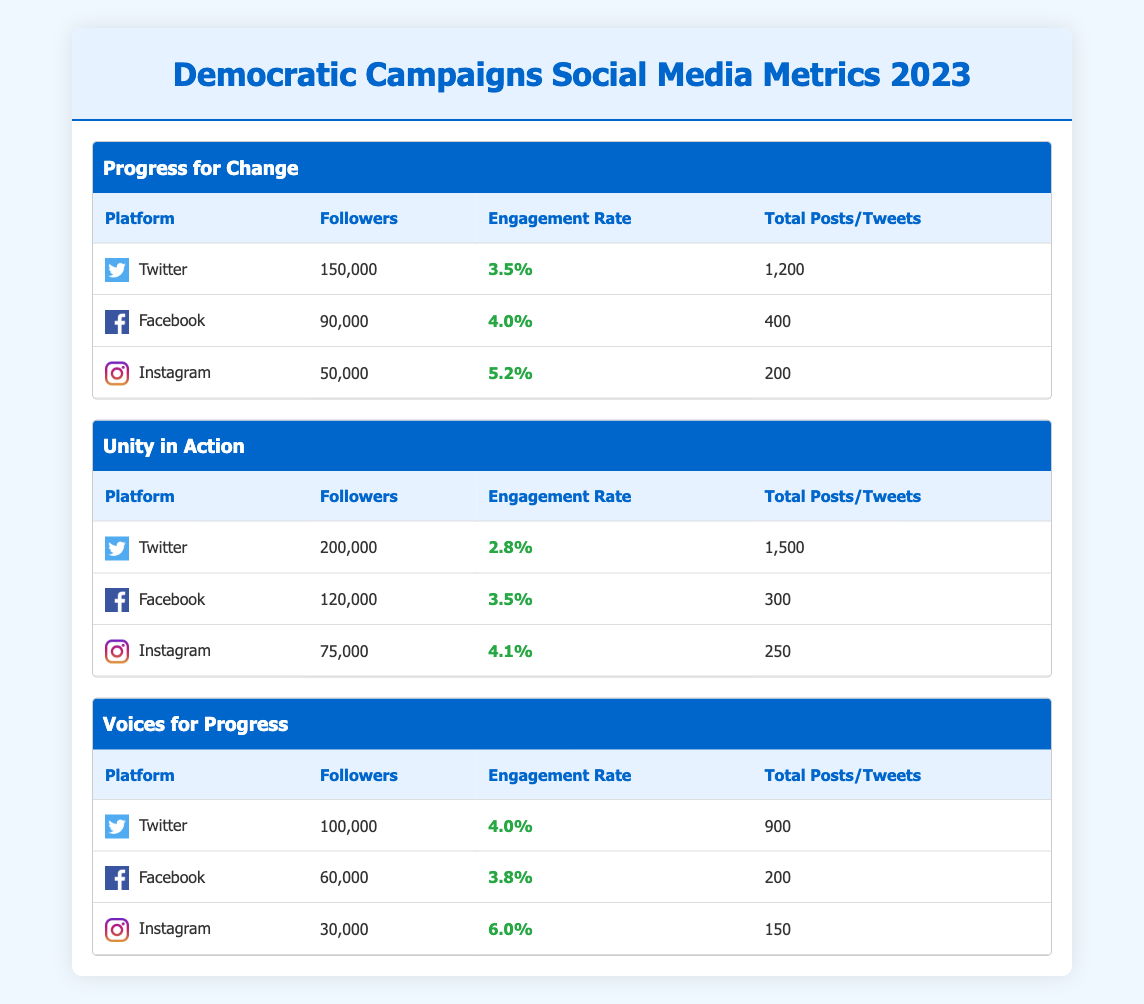What is the total number of followers across all social media platforms for the campaign "Progress for Change"? For the campaign "Progress for Change," we need to sum the followers from all platforms: Twitter (150,000) + Facebook (90,000) + Instagram (50,000). This gives us a total of 150,000 + 90,000 + 50,000 = 290,000 followers.
Answer: 290,000 Which campaign has the highest engagement rate on Instagram? Examining the engagement rates on Instagram: "Progress for Change" has 5.2%, "Unity in Action" has 4.1%, and "Voices for Progress" has 6.0%. "Voices for Progress" has the highest engagement rate on Instagram.
Answer: Voices for Progress Is it true that the campaign "Unity in Action" has more followers on Twitter than on Facebook? For "Unity in Action," the followers are 200,000 on Twitter and 120,000 on Facebook. Since 200,000 is greater than 120,000, the statement is true.
Answer: Yes What is the average engagement rate for the campaigns across all platforms? The engagement rates for all campaigns and platforms are: "Progress for Change" - 3.5% (Twitter) + 4.0% (Facebook) + 5.2% (Instagram), "Unity in Action" - 2.8% (Twitter) + 3.5% (Facebook) + 4.1% (Instagram), and "Voices for Progress" - 4.0% (Twitter) + 3.8% (Facebook) + 6.0% (Instagram). First, sum all engagement rates: (3.5 + 4.0 + 5.2 + 2.8 + 3.5 + 4.1 + 4.0 + 3.8 + 6.0) = 37.9%. Since there are 9 entries, we calculate the average: 37.9 / 9 ≈ 4.21%.
Answer: 4.21% How many total posts and tweets did the campaign "Voices for Progress" make? For "Voices for Progress," the totals are: Twitter (900), Facebook (200), Instagram (150). Adding them together gives us 900 + 200 + 150 = 1,250 posts and tweets in total for this campaign.
Answer: 1,250 